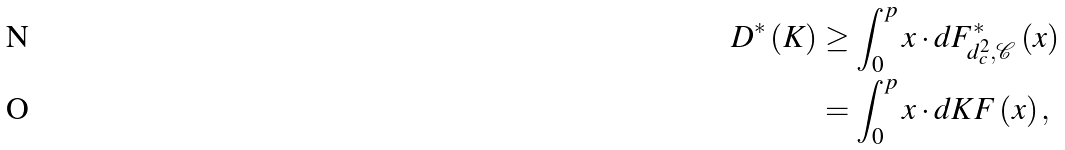<formula> <loc_0><loc_0><loc_500><loc_500>D ^ { * } \left ( K \right ) & \geq \int _ { 0 } ^ { p } x \cdot d F _ { d _ { c } ^ { 2 } , \mathcal { C } } ^ { * } \left ( x \right ) \\ & = \int _ { 0 } ^ { p } x \cdot d K F \left ( x \right ) ,</formula> 